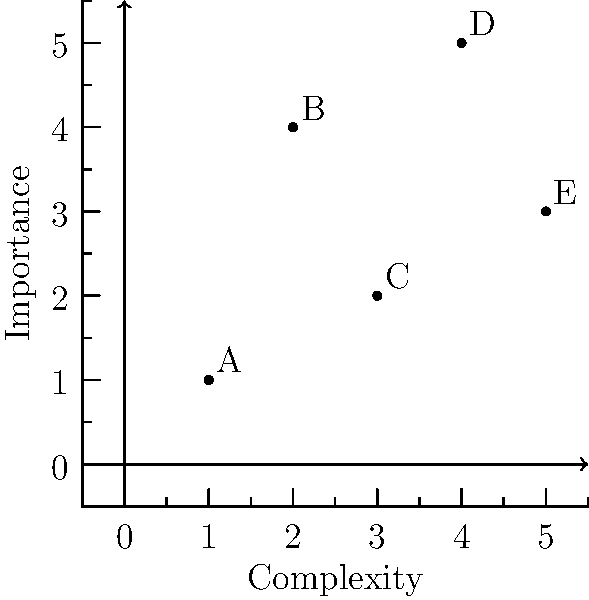In your latest novel, you've plotted the relationships between five main characters (A, B, C, D, and E) on a coordinate plane. The x-axis represents the complexity of the character's role in the story, while the y-axis represents their importance to the plot. Based on the graph, which character has the most complex role while being of moderate importance to the story? To answer this question, we need to analyze the positions of the characters on the coordinate plane:

1. First, identify the character with the highest x-coordinate (complexity):
   A(1,1), B(2,4), C(3,2), D(4,5), E(5,3)
   Character E has the highest x-coordinate at x=5.

2. Next, consider the y-coordinate (importance) of character E:
   E is at y=3, which is in the middle range of the y-axis.

3. Compare E's position with other characters:
   - A and C have lower complexity and lower importance
   - B has lower complexity but higher importance
   - D has slightly lower complexity but higher importance

4. Confirm that E indeed has the most complex role (highest x-value) while maintaining a moderate importance (middle range y-value).

Therefore, character E best fits the description of having the most complex role while being of moderate importance to the story.
Answer: E 